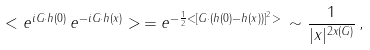Convert formula to latex. <formula><loc_0><loc_0><loc_500><loc_500>< e ^ { i { G } \cdot { h } ( 0 ) } \, e ^ { - i { G } \cdot { h } ( { x } ) } > \, = e ^ { - \frac { 1 } { 2 } < [ { G } \cdot ( { h } ( 0 ) - { h } ( { x } ) ) ] ^ { 2 } > } \, \sim \frac { 1 } { | { x } | ^ { 2 x ( { G } ) } } \, ,</formula> 